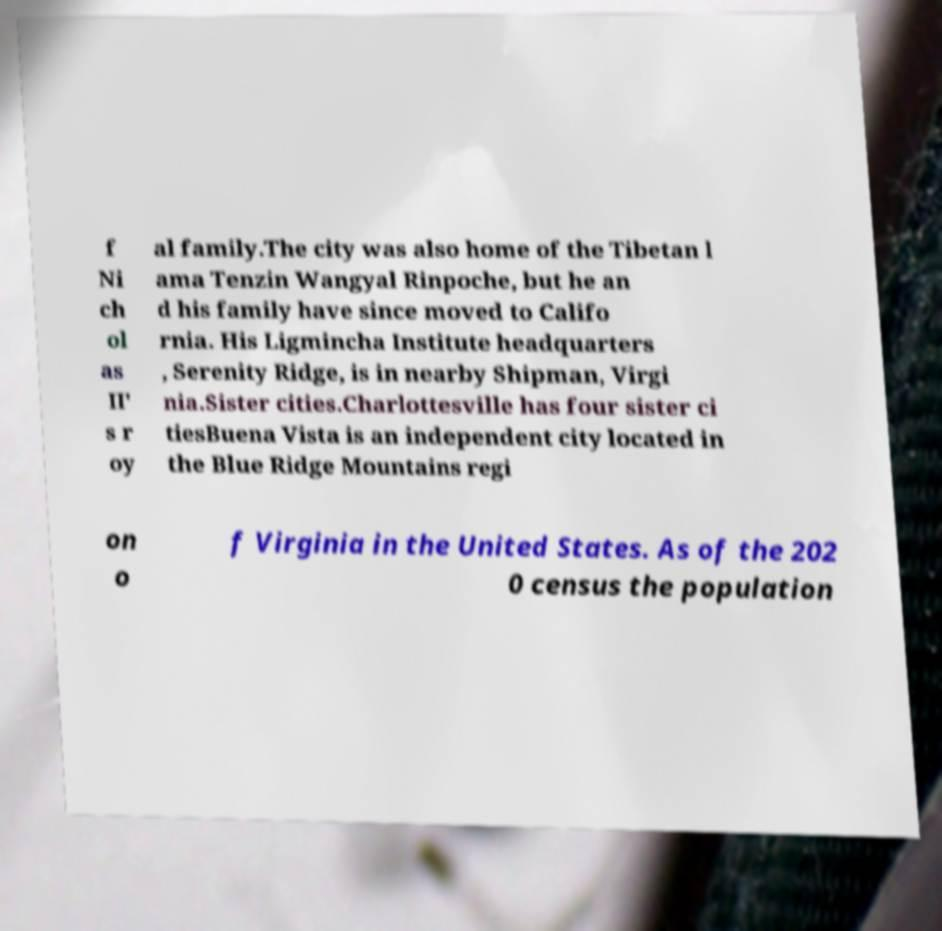For documentation purposes, I need the text within this image transcribed. Could you provide that? f Ni ch ol as II' s r oy al family.The city was also home of the Tibetan l ama Tenzin Wangyal Rinpoche, but he an d his family have since moved to Califo rnia. His Ligmincha Institute headquarters , Serenity Ridge, is in nearby Shipman, Virgi nia.Sister cities.Charlottesville has four sister ci tiesBuena Vista is an independent city located in the Blue Ridge Mountains regi on o f Virginia in the United States. As of the 202 0 census the population 